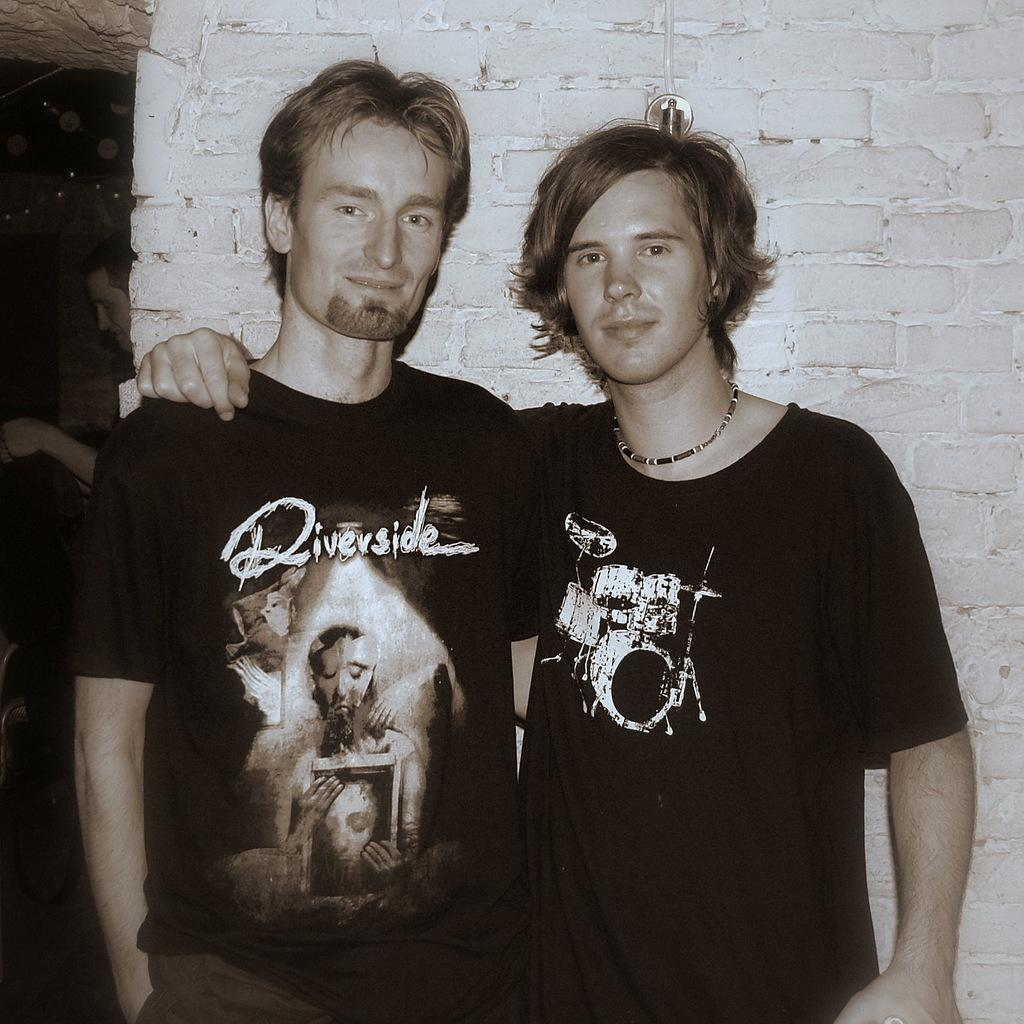How many people are in the image? There are two men standing in the middle of the image. What are the men wearing? The men are wearing t-shirts. What can be seen in the background of the image? There is a wall in the background of the image. What is the color scheme of the image? The image is in black and white color. What type of lipstick is the man wearing in the image? There is no lipstick or indication of makeup in the image, as the men are wearing t-shirts and the image is in black and white color. Can you tell me how many cups are on the table in the image? There is no table or cups present in the image; it features two men standing in the middle of the image. 